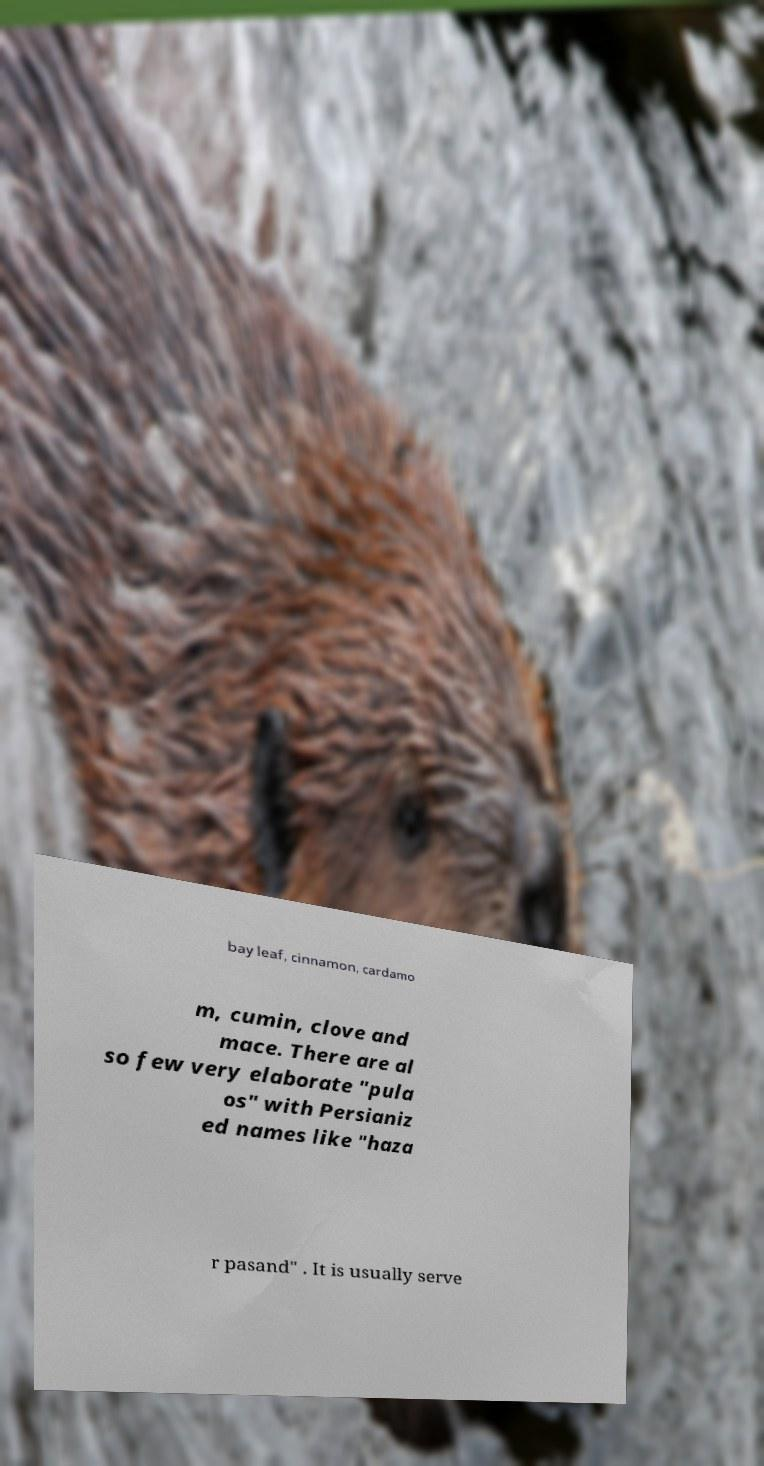Can you accurately transcribe the text from the provided image for me? bay leaf, cinnamon, cardamo m, cumin, clove and mace. There are al so few very elaborate "pula os" with Persianiz ed names like "haza r pasand" . It is usually serve 